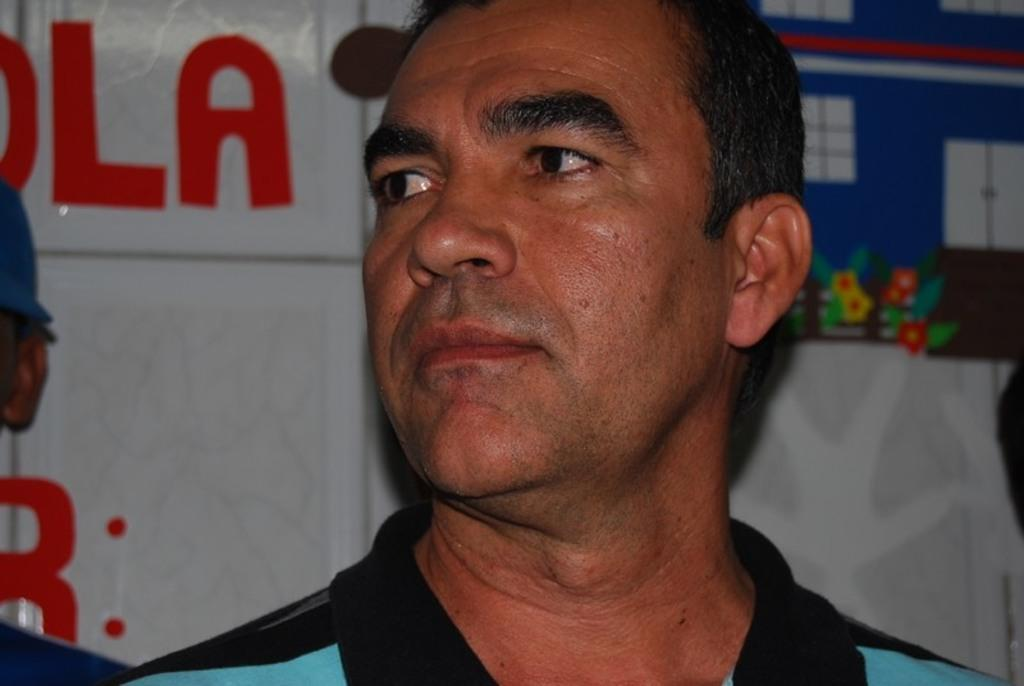What is the main subject of the image? There is a person in the image. What is the person doing in the image? The person is looking at someone. What can be seen in the background of the image? There is a white poster in the background. What is depicted on the poster? The poster has images of flowers and windows. Is there any text on the poster? Yes, there is text on the poster. How many lizards are crawling on the person's dress in the image? There are no lizards present in the image, and the person is not wearing a dress. What type of pie is being served on the poster? There is no pie depicted on the poster; it features images of flowers and windows. 